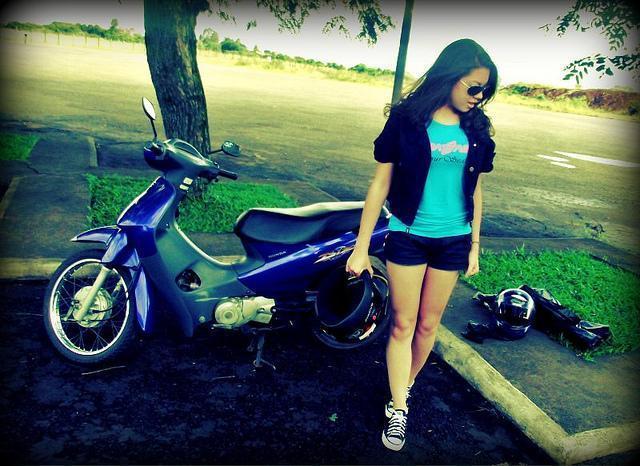How many cats are present?
Give a very brief answer. 0. 